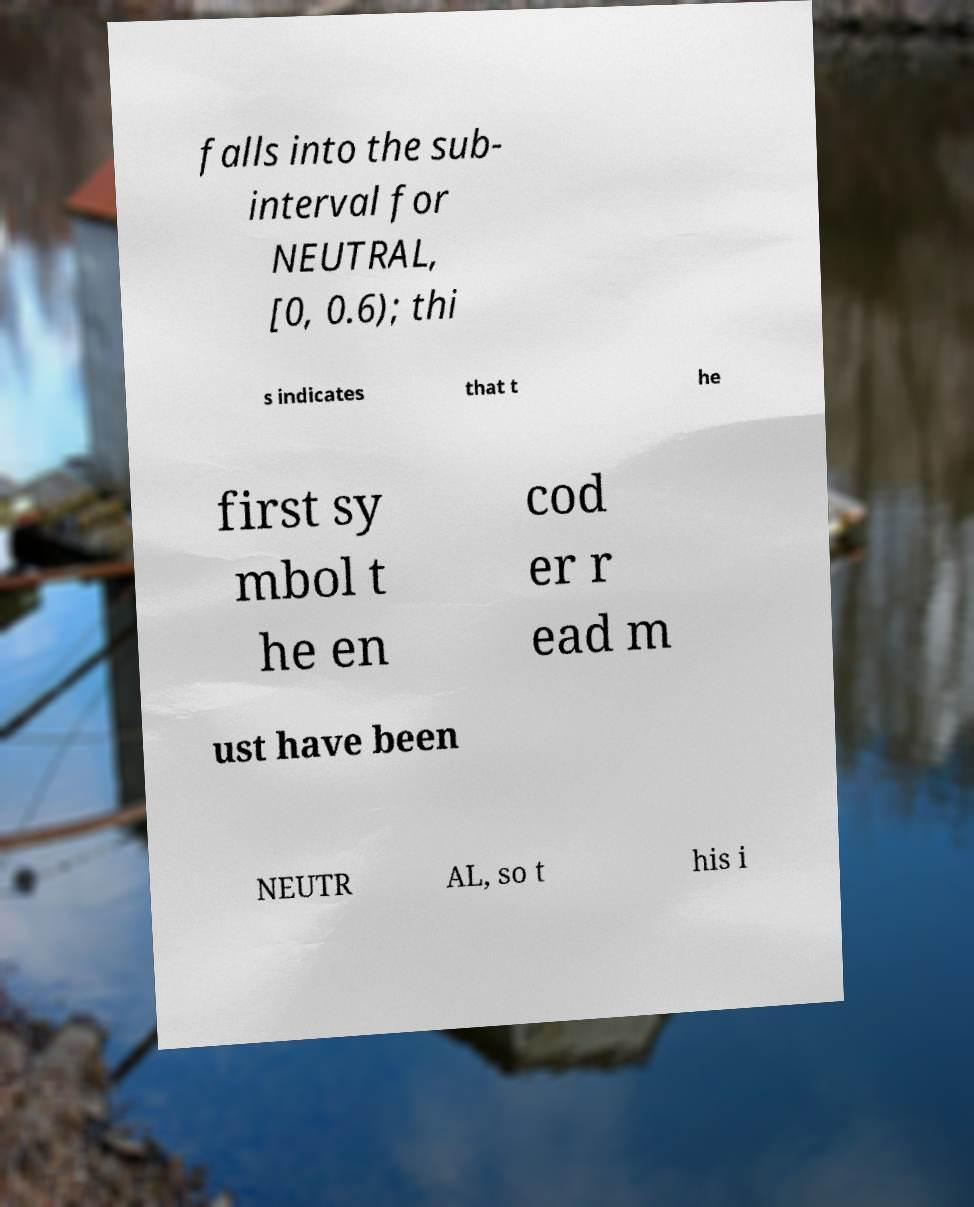What messages or text are displayed in this image? I need them in a readable, typed format. falls into the sub- interval for NEUTRAL, [0, 0.6); thi s indicates that t he first sy mbol t he en cod er r ead m ust have been NEUTR AL, so t his i 